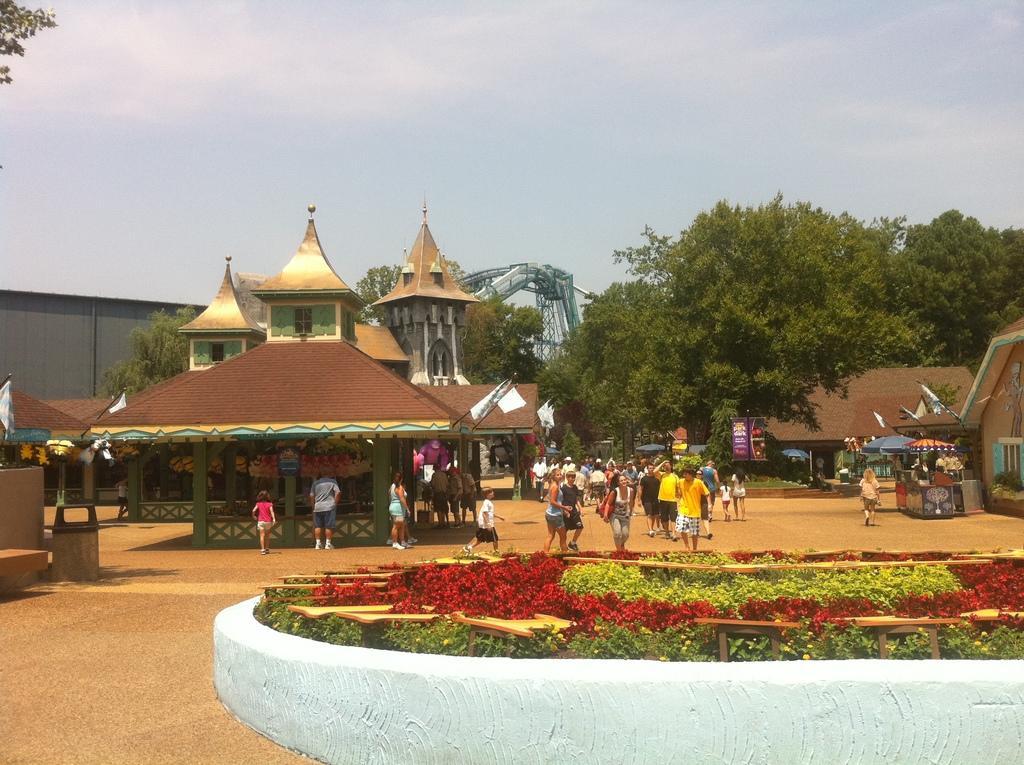Describe this image in one or two sentences. In this image at front there are flowers. At the center people are standing on the road. At the background there are buildings, trees and sky. 